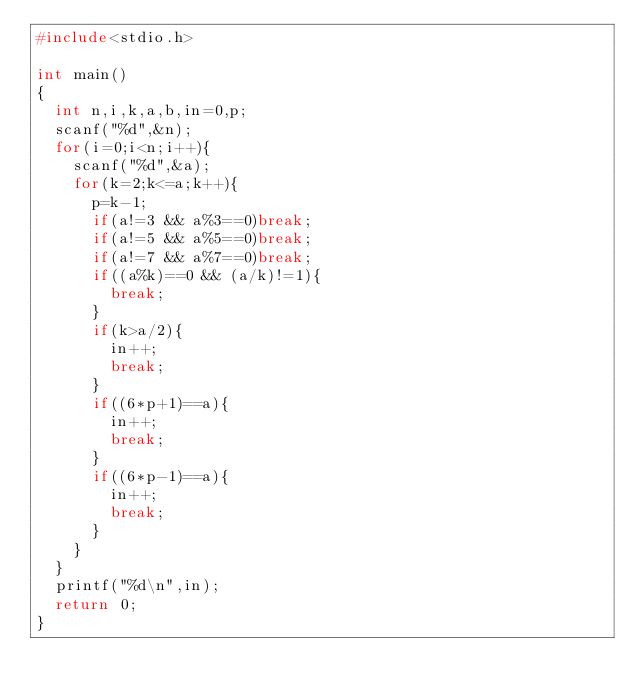<code> <loc_0><loc_0><loc_500><loc_500><_C_>#include<stdio.h>

int main()
{
  int n,i,k,a,b,in=0,p;
  scanf("%d",&n);
  for(i=0;i<n;i++){
    scanf("%d",&a);
    for(k=2;k<=a;k++){
      p=k-1;
      if(a!=3 && a%3==0)break;
      if(a!=5 && a%5==0)break;
      if(a!=7 && a%7==0)break;
      if((a%k)==0 && (a/k)!=1){
        break;
      }
      if(k>a/2){
        in++;
        break;
      }
      if((6*p+1)==a){
        in++;
        break;
      }
      if((6*p-1)==a){
        in++;
        break;
      }
    }
  }
  printf("%d\n",in);
  return 0;
}
</code> 